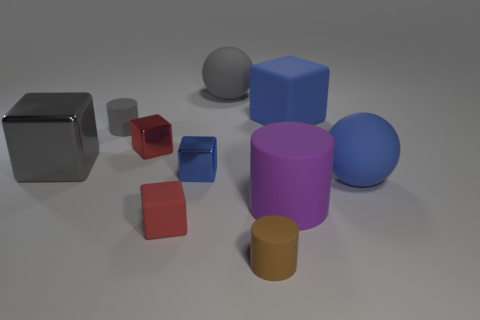Subtract 3 blocks. How many blocks are left? 2 Subtract all blue metal cubes. How many cubes are left? 4 Subtract all blue balls. How many balls are left? 1 Subtract all balls. How many objects are left? 8 Add 9 small brown things. How many small brown things are left? 10 Add 1 large shiny balls. How many large shiny balls exist? 1 Subtract 0 green cubes. How many objects are left? 10 Subtract all brown cylinders. Subtract all green spheres. How many cylinders are left? 2 Subtract all purple cylinders. How many gray spheres are left? 1 Subtract all tiny red objects. Subtract all big rubber blocks. How many objects are left? 7 